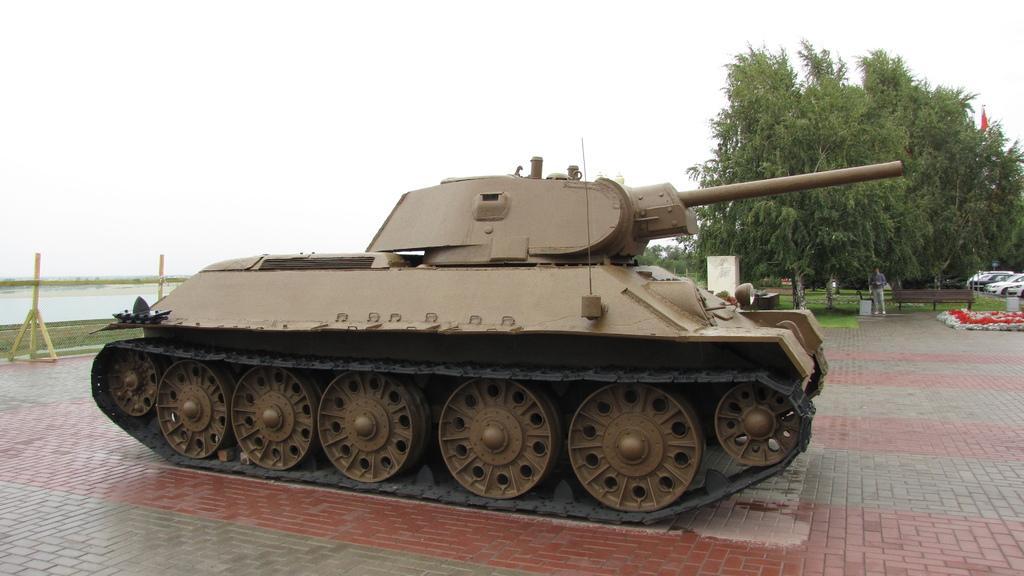Describe this image in one or two sentences. There is a war tank. A man is standing at the back. There are trees, bench, a flag, vehicles and water at the left. 